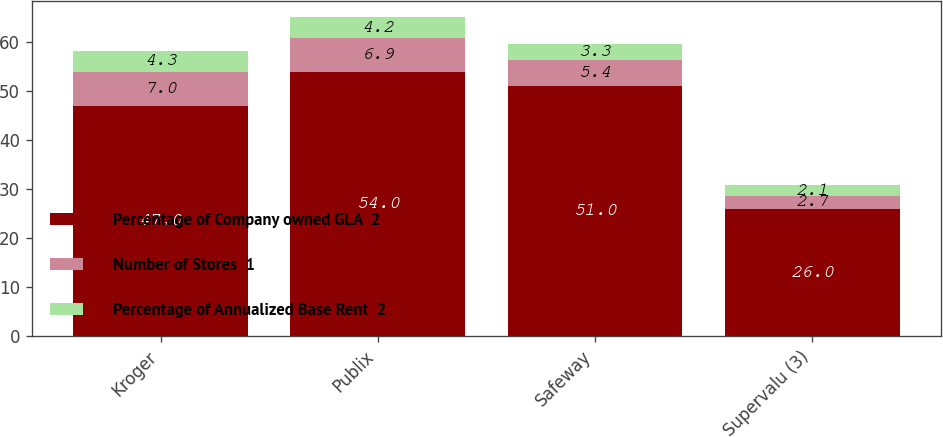<chart> <loc_0><loc_0><loc_500><loc_500><stacked_bar_chart><ecel><fcel>Kroger<fcel>Publix<fcel>Safeway<fcel>Supervalu (3)<nl><fcel>Percentage of Company owned GLA  2<fcel>47<fcel>54<fcel>51<fcel>26<nl><fcel>Number of Stores  1<fcel>7<fcel>6.9<fcel>5.4<fcel>2.7<nl><fcel>Percentage of Annualized Base Rent  2<fcel>4.3<fcel>4.2<fcel>3.3<fcel>2.1<nl></chart> 